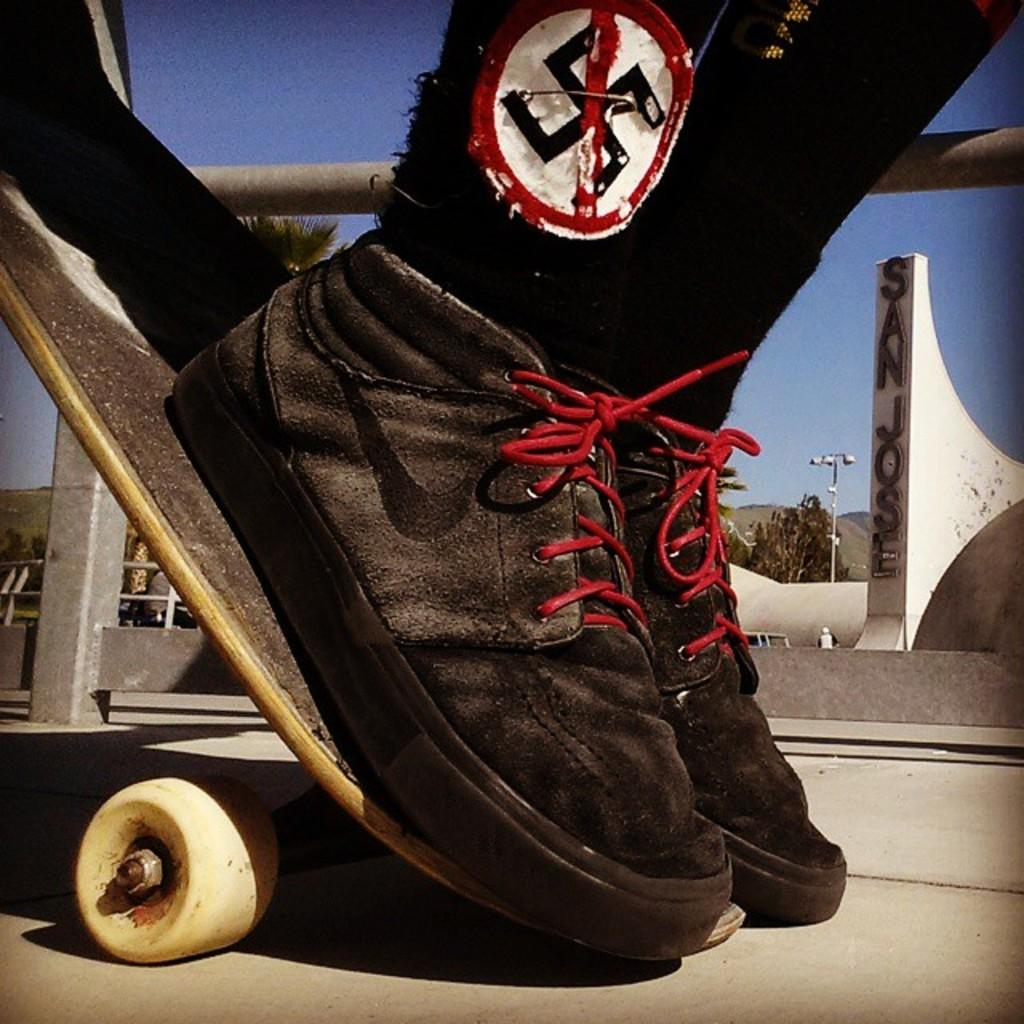What is the main object in the image? There is a skateboard in the image. What type of footwear is visible in the image? There are black color shoes in the image. What can be seen in the background of the image? There is a street lamp and trees in the background of the image. What is visible at the top of the image? The sky is visible at the top of the image. What type of produce is being sold at the skateboard shop in the image? There is no indication of a skateboard shop or produce being sold in the image. 